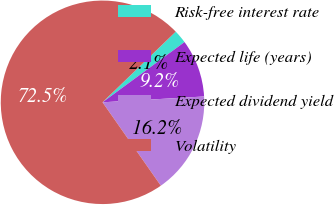<chart> <loc_0><loc_0><loc_500><loc_500><pie_chart><fcel>Risk-free interest rate<fcel>Expected life (years)<fcel>Expected dividend yield<fcel>Volatility<nl><fcel>2.13%<fcel>9.17%<fcel>16.2%<fcel>72.5%<nl></chart> 